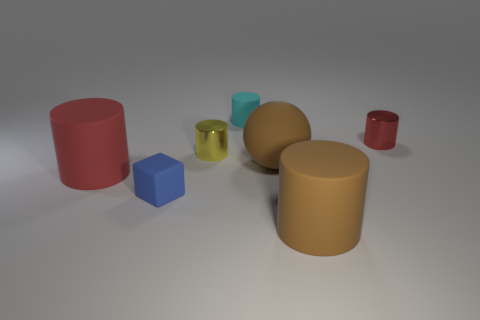Which objects in the image appear to have a similar texture? The red cylinder on the far left and the large tan sphere in the center have a similar matte texture, suggesting a non-reflective, smooth surface, contrasted by the more reflective textures of the other objects. 